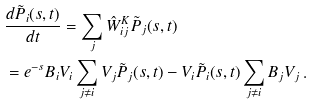<formula> <loc_0><loc_0><loc_500><loc_500>& \frac { d \tilde { P } _ { i } ( s , t ) } { d t } = \sum _ { j } \hat { W } ^ { K } _ { i j } \tilde { P } _ { j } ( s , t ) \\ & = e ^ { - s } B _ { i } V _ { i } \sum _ { j \neq i } V _ { j } \tilde { P } _ { j } ( s , t ) - V _ { i } \tilde { P } _ { i } ( s , t ) \sum _ { j \neq i } B _ { j } V _ { j } \, .</formula> 